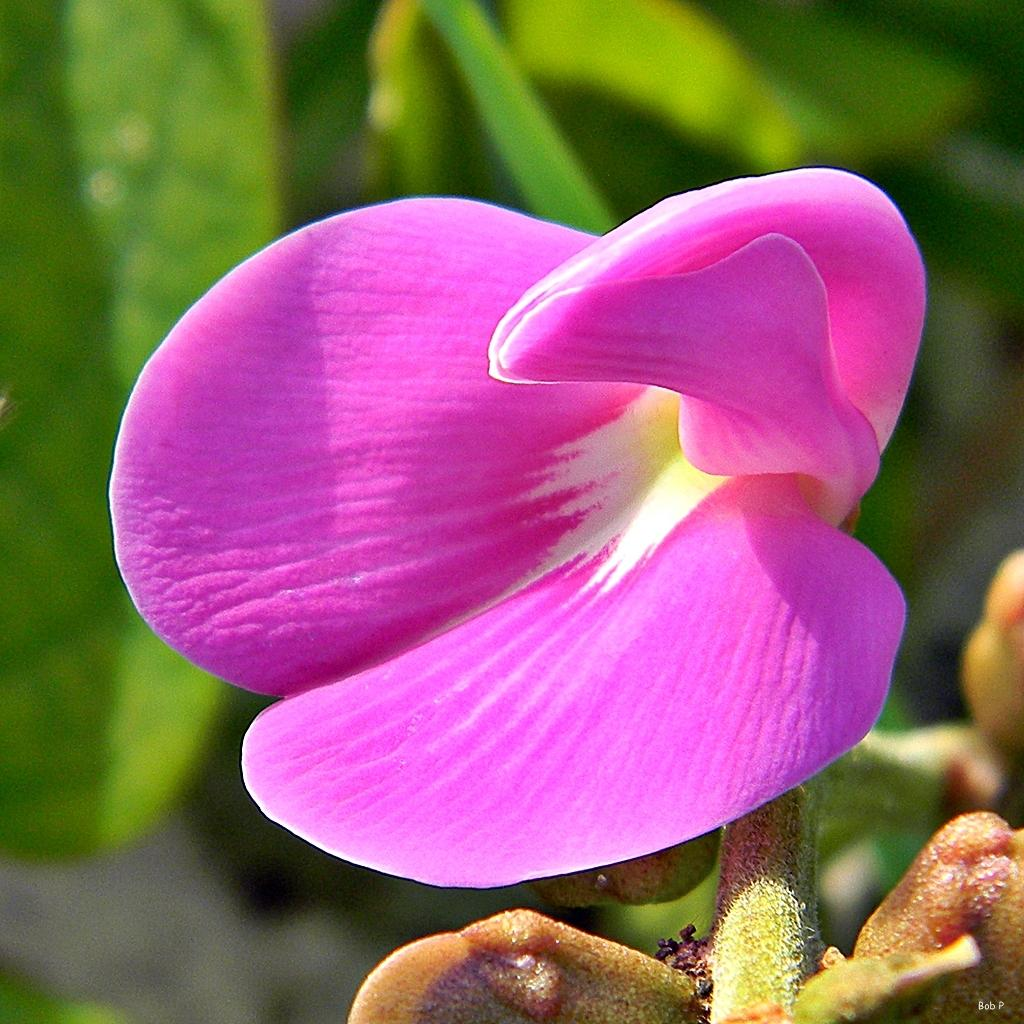What is there is a flower in the image, what color is it? There is a pink flower in the image. Where is the pink flower located in the image? The pink flower is in the middle of the image. What can be seen in the background of the image? There are green leaves in the background of the image. Can you see a kitty wearing a shoe in the image? No, there is no kitty or shoe present in the image. 